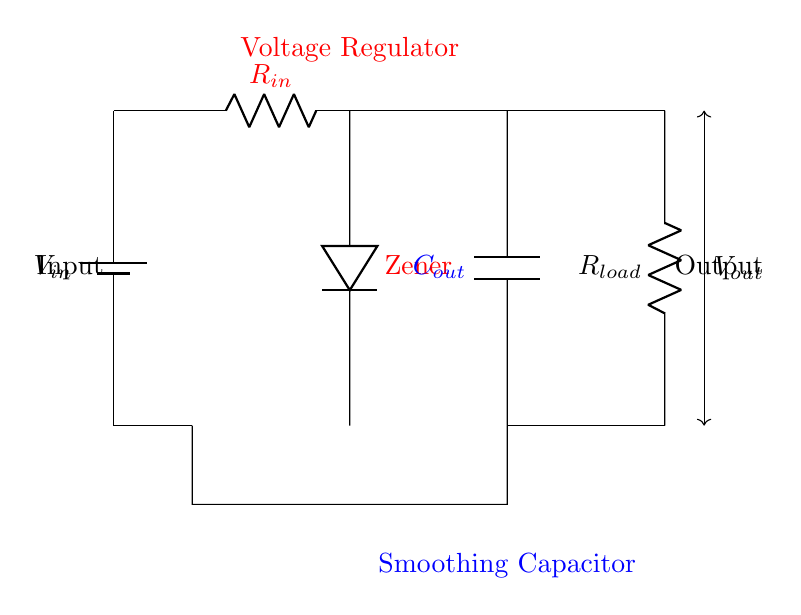What type of voltage regulator is used in this circuit? The circuit uses a Zener diode as the voltage regulator, shown clearly by the label next to it.
Answer: Zener What is the purpose of the capacitor in this circuit? The capacitor's role is to smooth the output voltage by reducing voltage ripple, which is indicated by its label as a smoothing capacitor.
Answer: Smoothing What is the resistance value of the input resistor labeled in the circuit? The circuit does not specify a numerical value for the resistor, but it is labeled as R in the diagram. Consequently, the answer is based on the label's context.
Answer: R What is the relationship between Vout and Vin in this circuit? The output voltage (Vout) will be regulated and should be lower than or equal to the input voltage (Vin) due to the function of the Zener diode, which only allows a specific voltage level.
Answer: Vout ≤ Vin How many load resistors are depicted in the circuit? There is one load resistor present, identified as R_load in the diagram. The answer is directly observed from the components shown.
Answer: One What is the effect of the Zener diode breaking down? When the Zener diode breaks down, it regulates the output voltage to a constant value, preventing it from rising above this level, thus providing protection to sensitive devices.
Answer: Protects voltage What will happen if the power supply voltage exceeds the Zener diode specifications? If the input voltage exceeds the specifications, it may damage the Zener diode and potentially the connected load, as the regulation function will exceed its limits, risking higher output.
Answer: Damage 